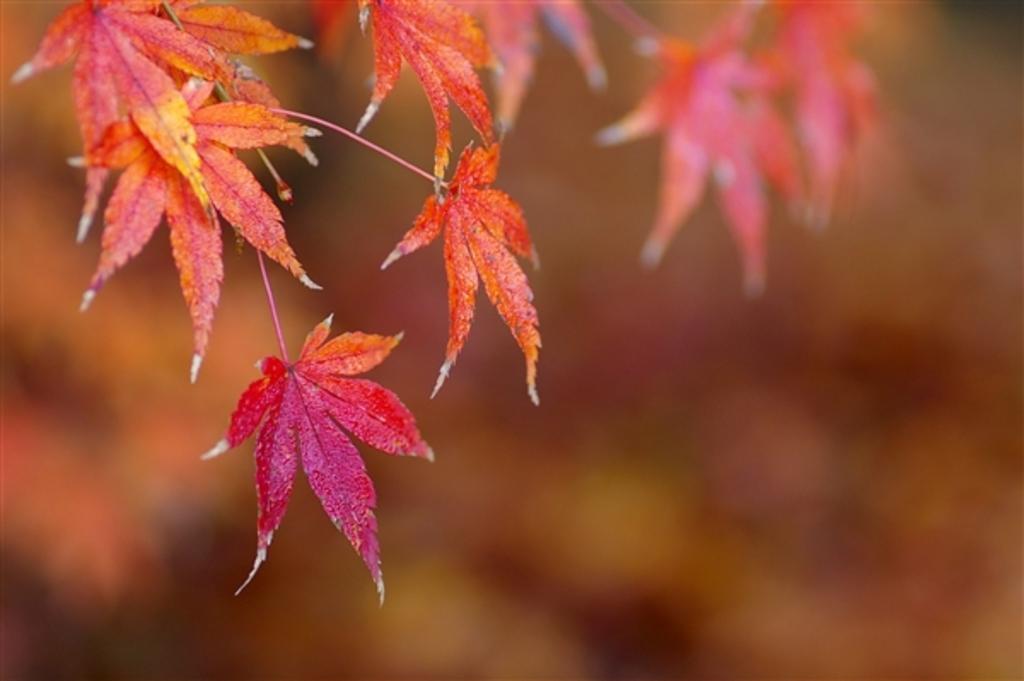Can you describe this image briefly? In the picture we can see some maple leaves which are dark pink in color and some are orange in color, and behind it we can see some leaves which are not visible clearly. 